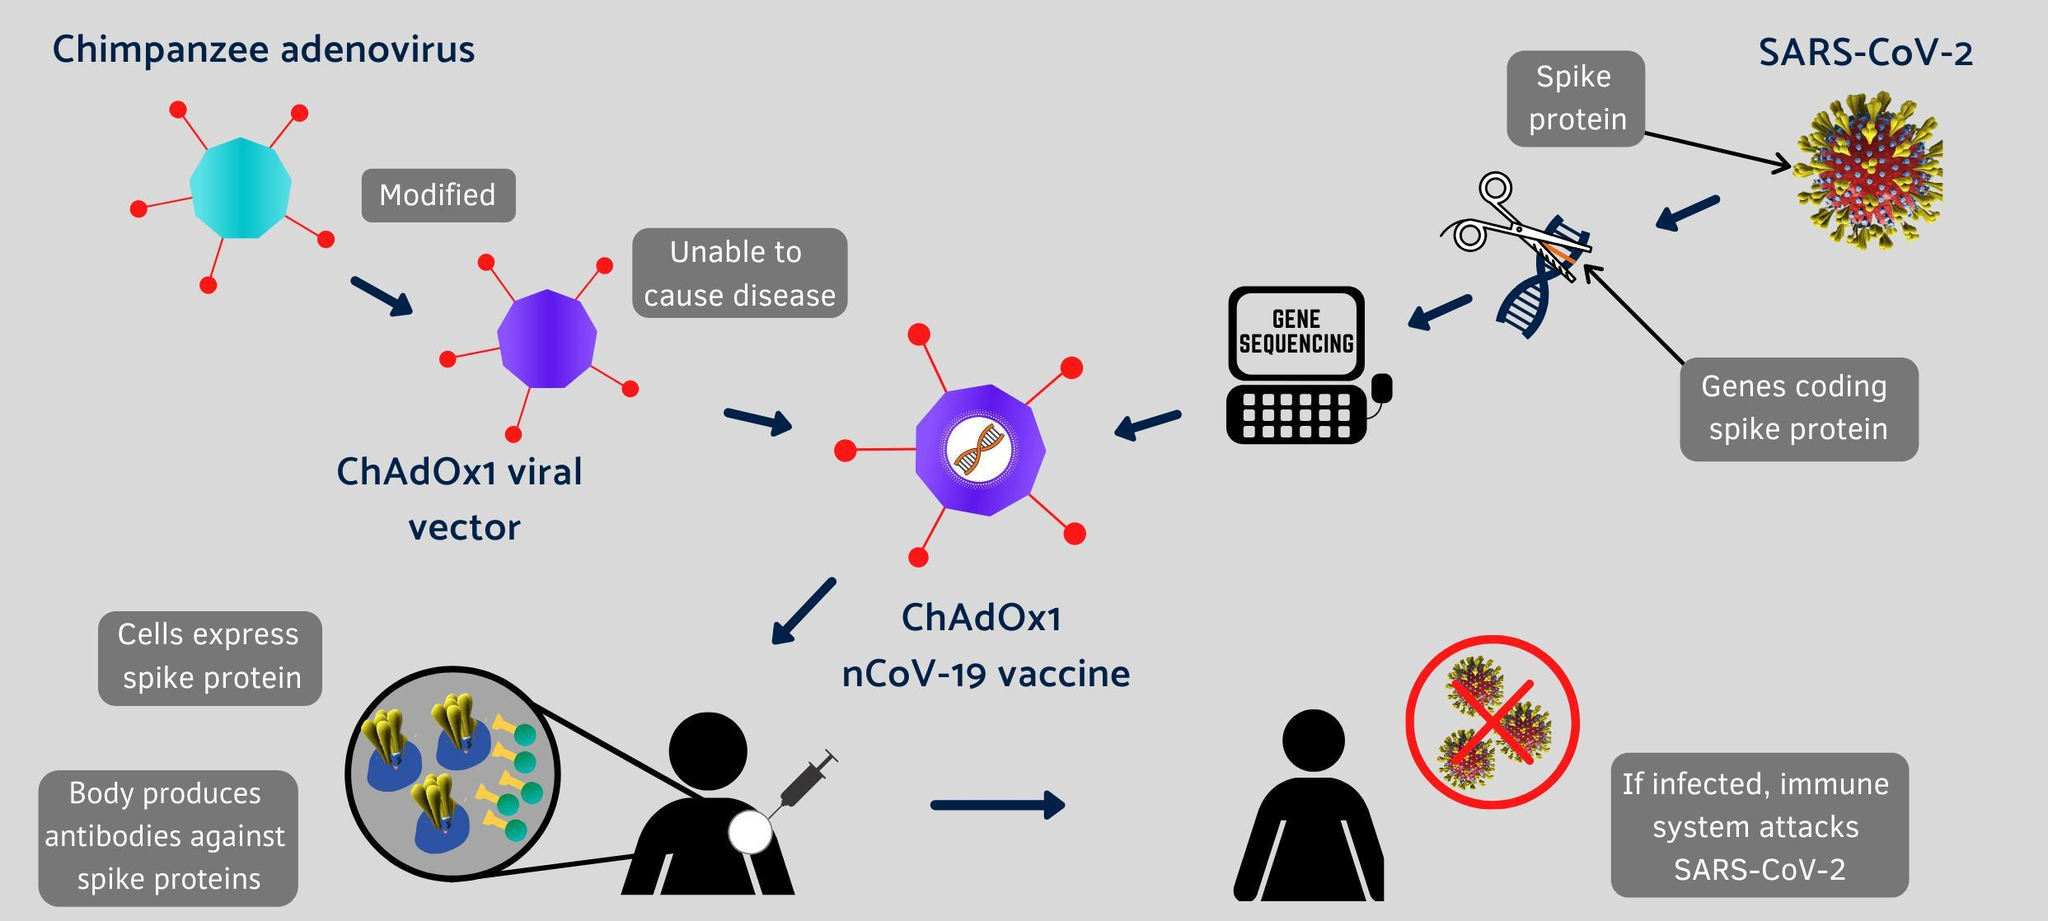what is modified to ChAdOx1 viral vector
Answer the question with a short phrase. Chimpanzee adenovirus what is written on the computer screen gene sequencing What helps body produce antibodies against spike proteins ChAdOx1 nCoV-19 vaccine 